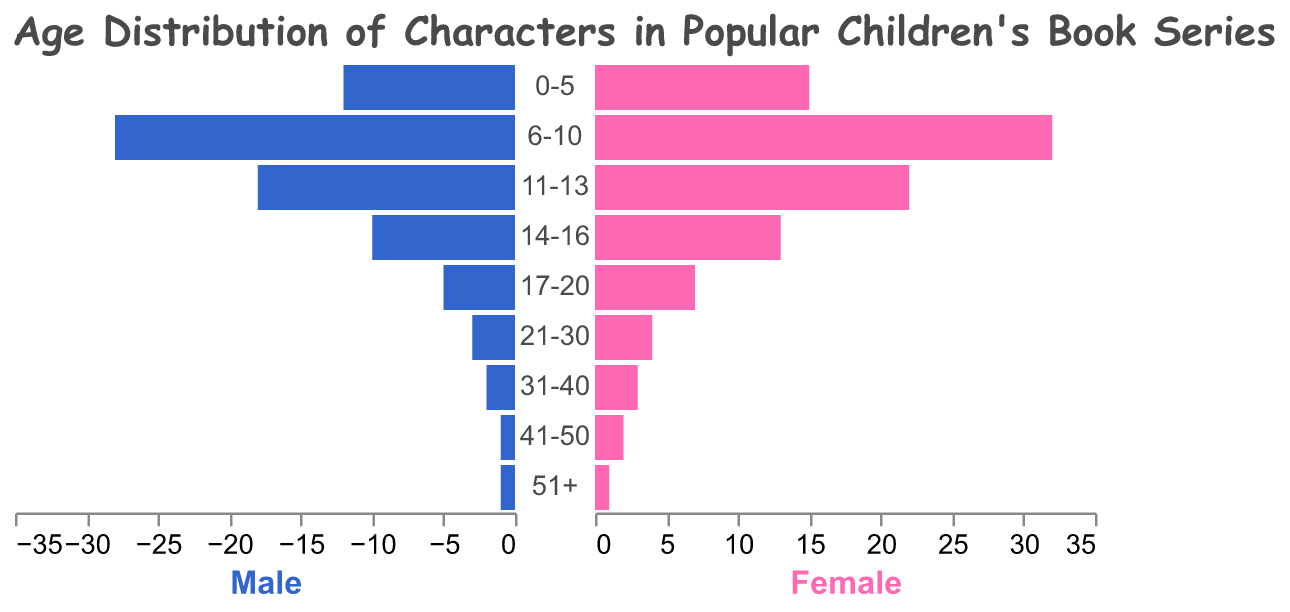What is the title of the figure? The title of the figure is written at the top and is "Age Distribution of Characters in Popular Children's Book Series."
Answer: Age Distribution of Characters in Popular Children's Book Series How many age groups are present in the data? The age groups are listed vertically along the y-axis. Counting these, there are a total of 9 age groups.
Answer: 9 Which age group has the highest number of male characters? To find the age group with the highest number of male characters, look at the blue bars' length toward the negative side. The age group "6-10" has the longest blue bar.
Answer: 6-10 What is the difference in the number of female characters between the age groups 0-5 and 6-10? The number of female characters in the age group 0-5 is 15, and in the age group 6-10 is 32. The difference is 32 - 15.
Answer: 17 What is the total number of characters aged 11-13? To find the total number, add the numbers for male and female characters in the age group 11-13. There are 18 males and 22 females, so 18 + 22.
Answer: 40 Which gender has more characters aged 14-16? Compare the lengths of the blue bar (male) and the pink bar (female) for the age group 14-16. The pink bar is longer.
Answer: Female How many characters are aged 17-20 in total? Add the number of male and female characters in the age group 17-20. There are 5 males and 7 females, giving 5 + 7.
Answer: 12 What is the proportion of male characters aged 21-30 compared to the total number of characters in that age group? The age group 21-30 has 3 male characters and 4 female characters, giving a total of 3 + 4. The proportion of male characters is 3/7.
Answer: 3/7 Which age group has the smallest number of characters? Look for the age group with the shortest combined bars (both blue and pink). The age group 51+ has the smallest number, with just 1 male and 1 female.
Answer: 51+ Between the age groups 31-40 and 41-50, which has more female characters? Compare the lengths of the pink bars for the age groups 31-40 and 41-50. The age group 31-40 has a longer pink bar.
Answer: 31-40 